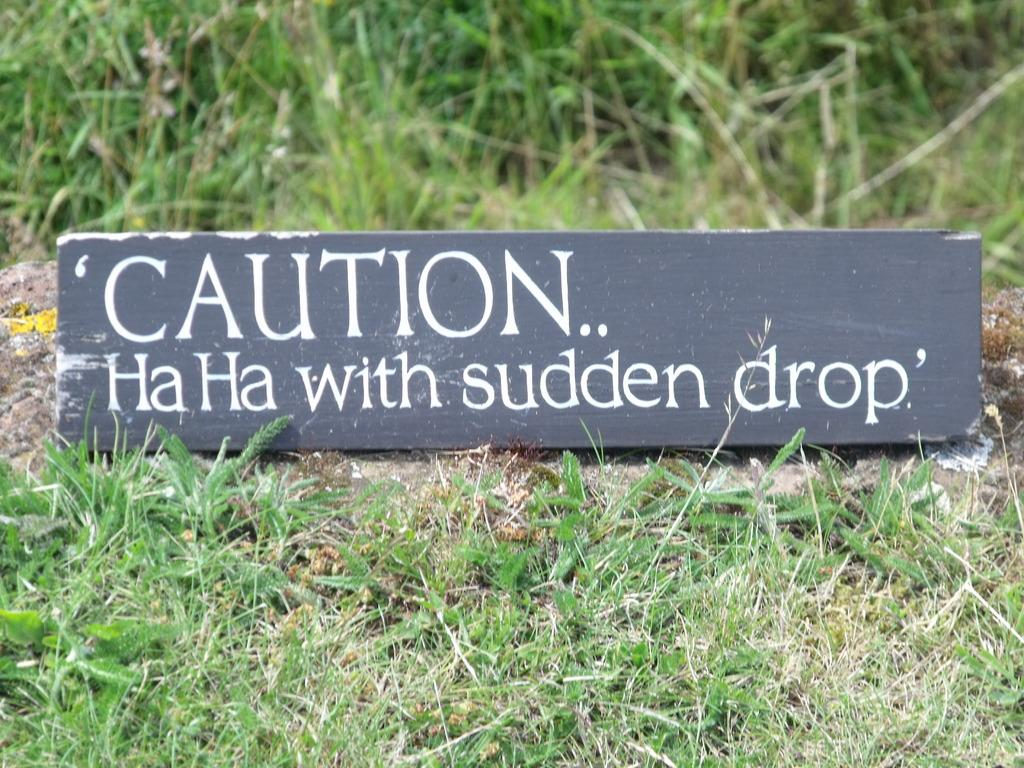What type of terrain is shown in the image? The image depicts a grassy land. What object with text can be seen in the image? There is a board with text written on it in the image. What health benefits can be gained from joining the grassy land in the image? There is no indication of health benefits or the need to join the grassy land in the image. 